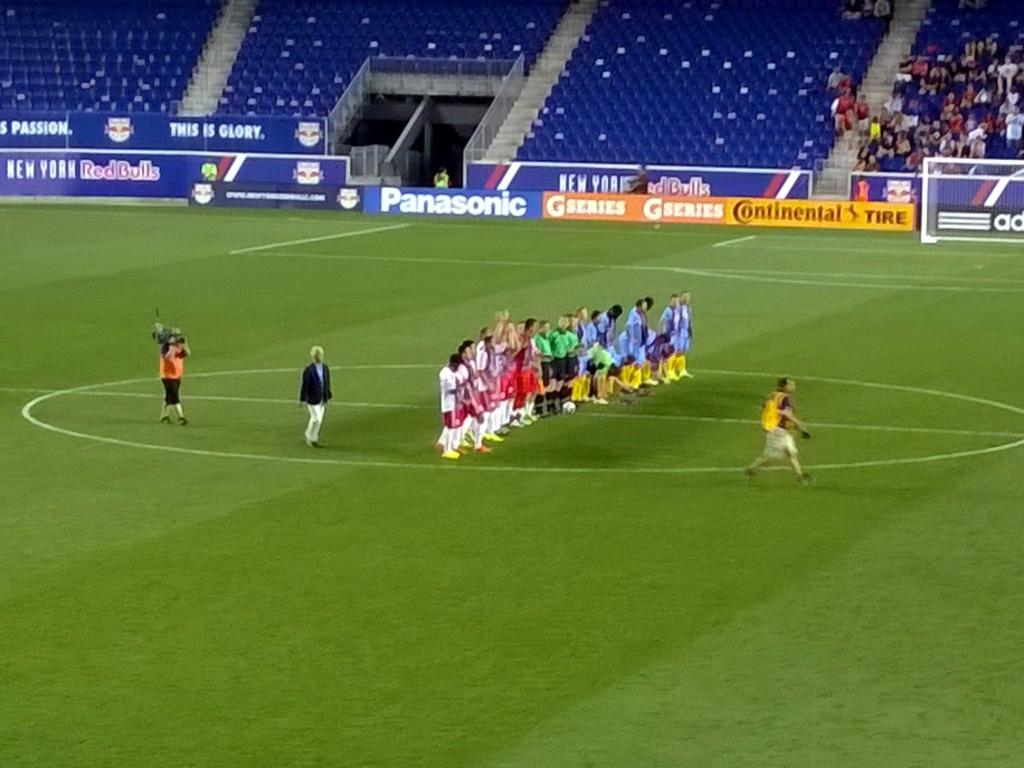<image>
Share a concise interpretation of the image provided. Athletes standing in a group in front of a Continental Tires sign. 